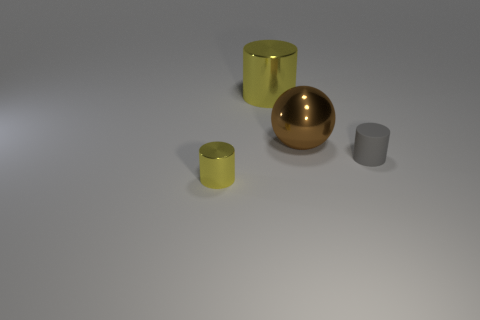How many other small cylinders are the same color as the tiny metal cylinder? There are two small cylinders in the image, one is yellow and the other is gray, like the tiny cylinder. Therefore, only one small cylinder shares the same gray color as the tiny metal cylinder. 